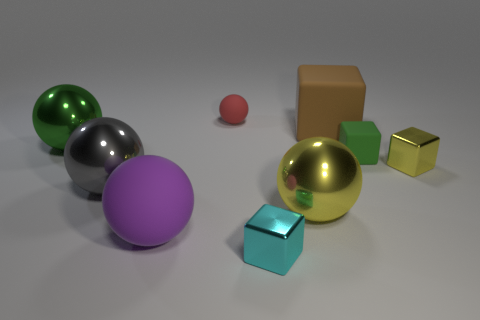There is a block right of the small green object in front of the red matte object; are there any small green things on the right side of it?
Your response must be concise. No. How many big things are shiny spheres or yellow objects?
Give a very brief answer. 3. What color is the rubber cube that is the same size as the gray object?
Provide a succinct answer. Brown. What number of brown rubber blocks are behind the small red matte object?
Provide a succinct answer. 0. Is there a purple thing made of the same material as the green sphere?
Offer a very short reply. No. What shape is the thing that is the same color as the small rubber cube?
Your response must be concise. Sphere. There is a large rubber thing to the left of the cyan metallic thing; what color is it?
Offer a very short reply. Purple. Are there the same number of green shiny spheres that are behind the big yellow metal object and metal objects left of the small yellow shiny block?
Ensure brevity in your answer.  No. What is the small object in front of the large yellow metal thing that is on the left side of the yellow shiny block made of?
Make the answer very short. Metal. How many objects are purple rubber spheres or things that are in front of the big matte cube?
Make the answer very short. 7. 